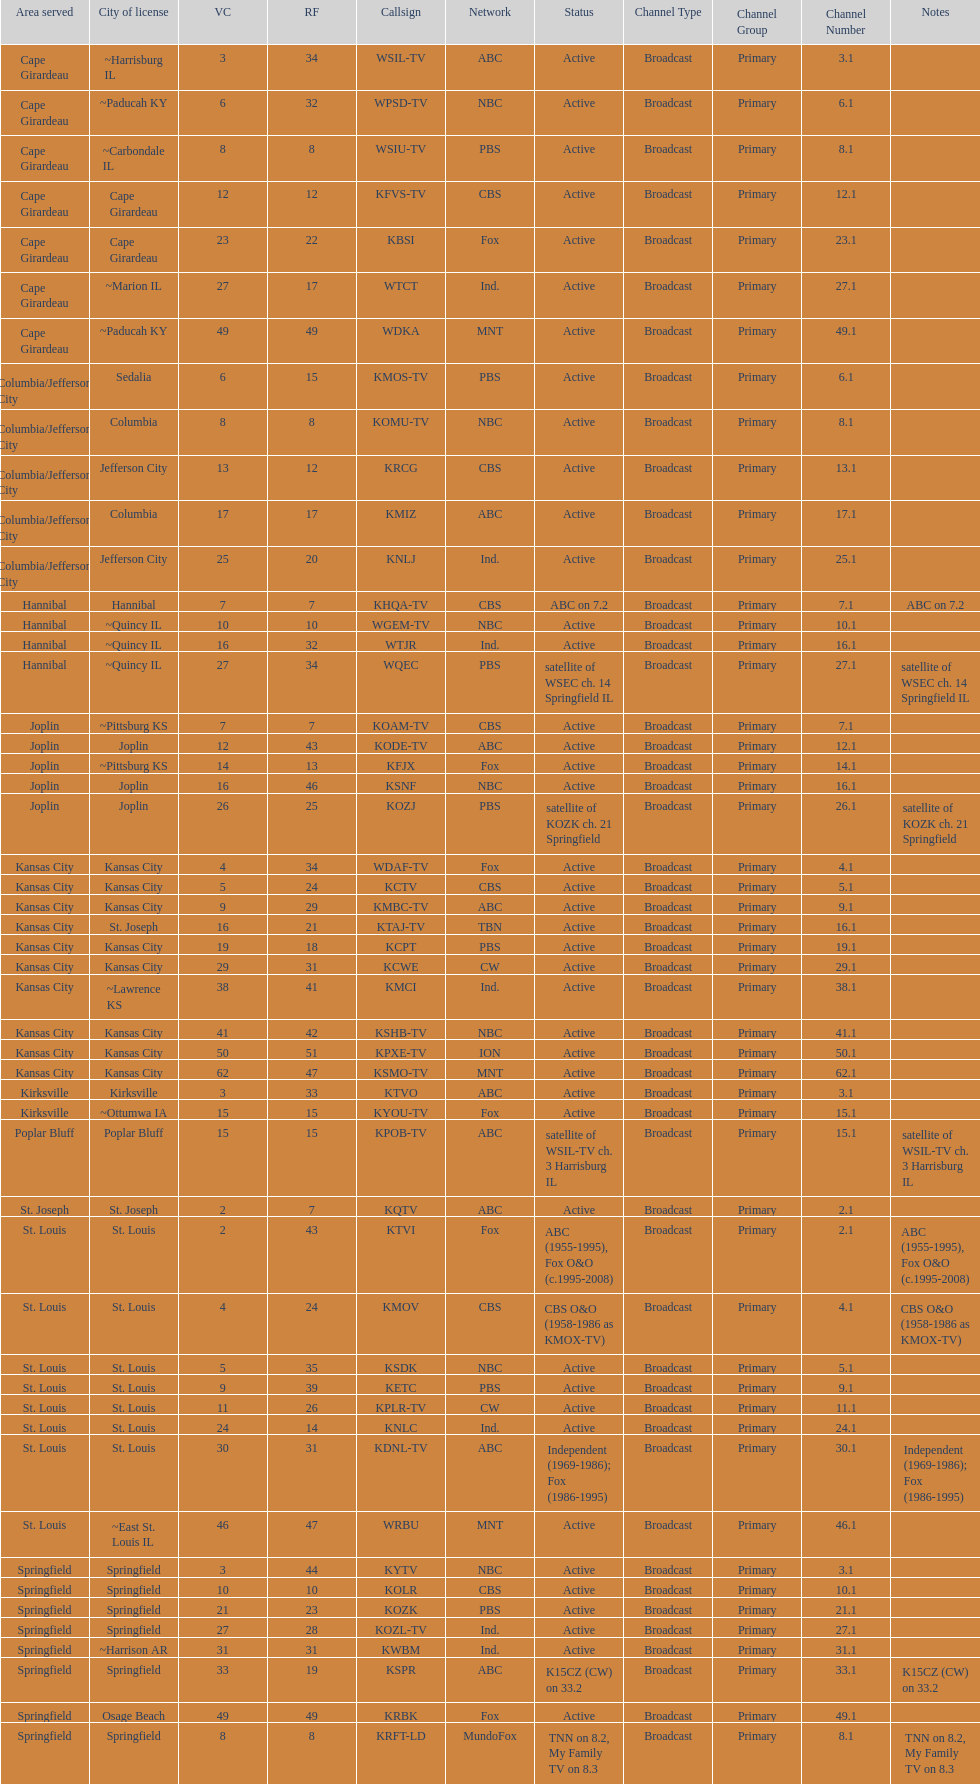What is the total number of stations serving the the cape girardeau area? 7. 